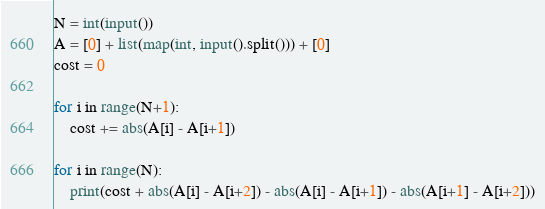<code> <loc_0><loc_0><loc_500><loc_500><_Python_>N = int(input())
A = [0] + list(map(int, input().split())) + [0]
cost = 0

for i in range(N+1):
    cost += abs(A[i] - A[i+1])

for i in range(N):
    print(cost + abs(A[i] - A[i+2]) - abs(A[i] - A[i+1]) - abs(A[i+1] - A[i+2]))</code> 